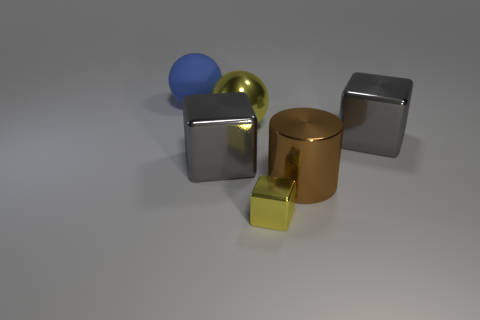Add 1 green objects. How many objects exist? 7 Subtract all cylinders. How many objects are left? 5 Subtract all big balls. Subtract all big metal spheres. How many objects are left? 3 Add 6 big yellow balls. How many big yellow balls are left? 7 Add 5 large matte cylinders. How many large matte cylinders exist? 5 Subtract 0 cyan cylinders. How many objects are left? 6 